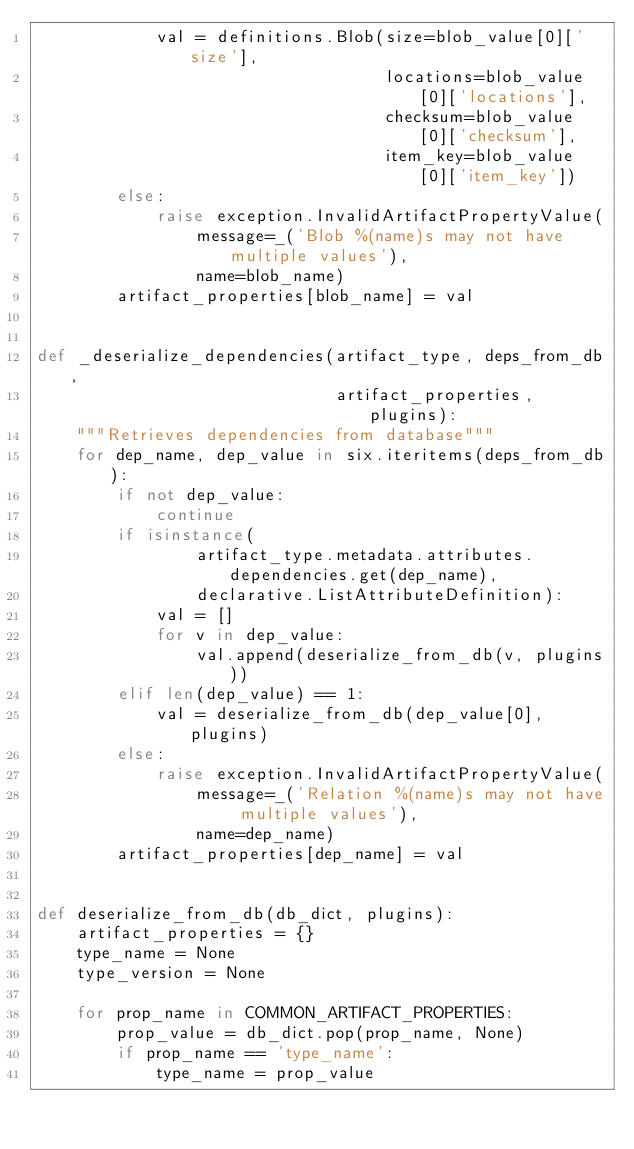Convert code to text. <code><loc_0><loc_0><loc_500><loc_500><_Python_>            val = definitions.Blob(size=blob_value[0]['size'],
                                   locations=blob_value[0]['locations'],
                                   checksum=blob_value[0]['checksum'],
                                   item_key=blob_value[0]['item_key'])
        else:
            raise exception.InvalidArtifactPropertyValue(
                message=_('Blob %(name)s may not have multiple values'),
                name=blob_name)
        artifact_properties[blob_name] = val


def _deserialize_dependencies(artifact_type, deps_from_db,
                              artifact_properties, plugins):
    """Retrieves dependencies from database"""
    for dep_name, dep_value in six.iteritems(deps_from_db):
        if not dep_value:
            continue
        if isinstance(
                artifact_type.metadata.attributes.dependencies.get(dep_name),
                declarative.ListAttributeDefinition):
            val = []
            for v in dep_value:
                val.append(deserialize_from_db(v, plugins))
        elif len(dep_value) == 1:
            val = deserialize_from_db(dep_value[0], plugins)
        else:
            raise exception.InvalidArtifactPropertyValue(
                message=_('Relation %(name)s may not have multiple values'),
                name=dep_name)
        artifact_properties[dep_name] = val


def deserialize_from_db(db_dict, plugins):
    artifact_properties = {}
    type_name = None
    type_version = None

    for prop_name in COMMON_ARTIFACT_PROPERTIES:
        prop_value = db_dict.pop(prop_name, None)
        if prop_name == 'type_name':
            type_name = prop_value</code> 